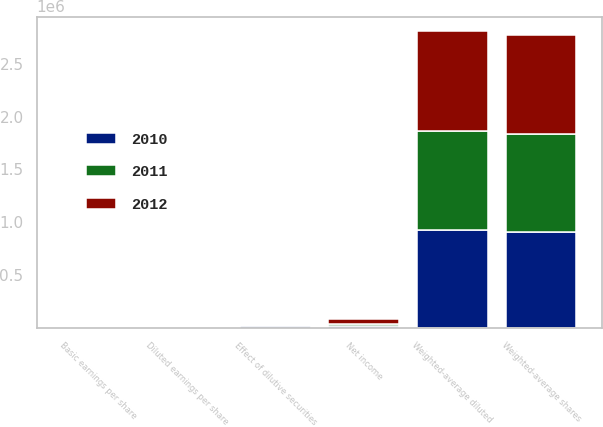<chart> <loc_0><loc_0><loc_500><loc_500><stacked_bar_chart><ecel><fcel>Net income<fcel>Weighted-average shares<fcel>Effect of dilutive securities<fcel>Weighted-average diluted<fcel>Basic earnings per share<fcel>Diluted earnings per share<nl><fcel>2012<fcel>41733<fcel>934818<fcel>10537<fcel>945355<fcel>44.64<fcel>44.15<nl><fcel>2011<fcel>25922<fcel>924258<fcel>12387<fcel>936645<fcel>28.05<fcel>27.68<nl><fcel>2010<fcel>14013<fcel>909461<fcel>15251<fcel>924712<fcel>15.41<fcel>15.15<nl></chart> 